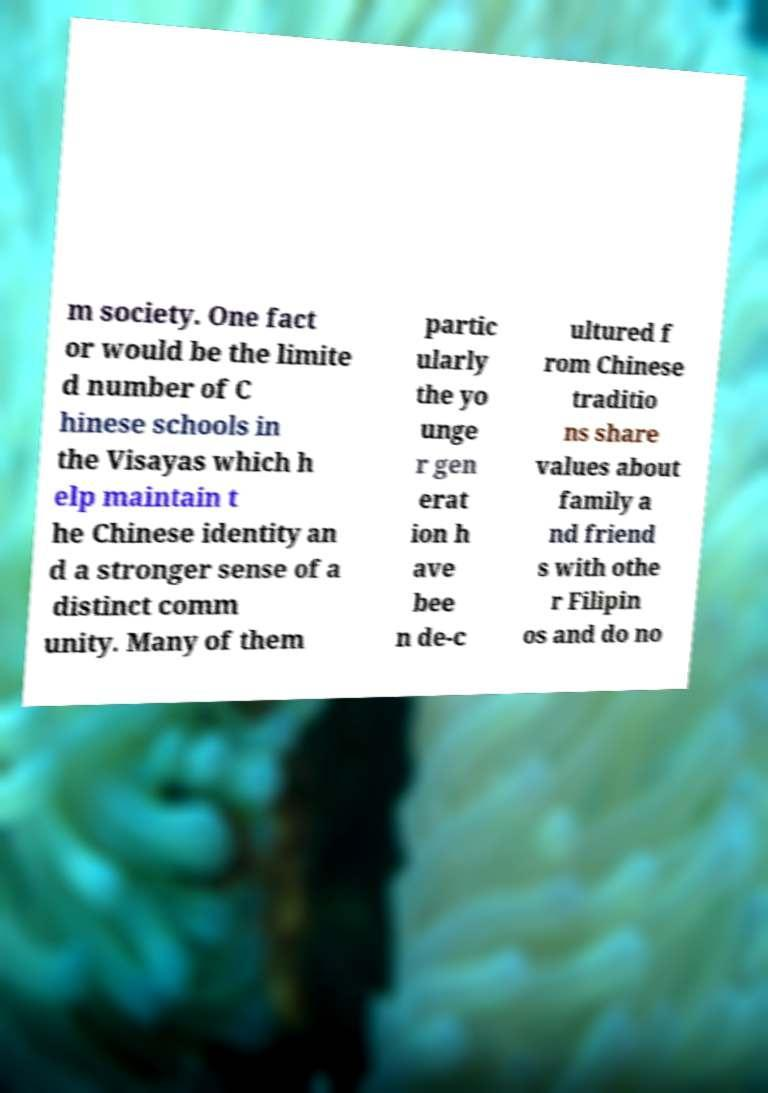Could you assist in decoding the text presented in this image and type it out clearly? m society. One fact or would be the limite d number of C hinese schools in the Visayas which h elp maintain t he Chinese identity an d a stronger sense of a distinct comm unity. Many of them partic ularly the yo unge r gen erat ion h ave bee n de-c ultured f rom Chinese traditio ns share values about family a nd friend s with othe r Filipin os and do no 